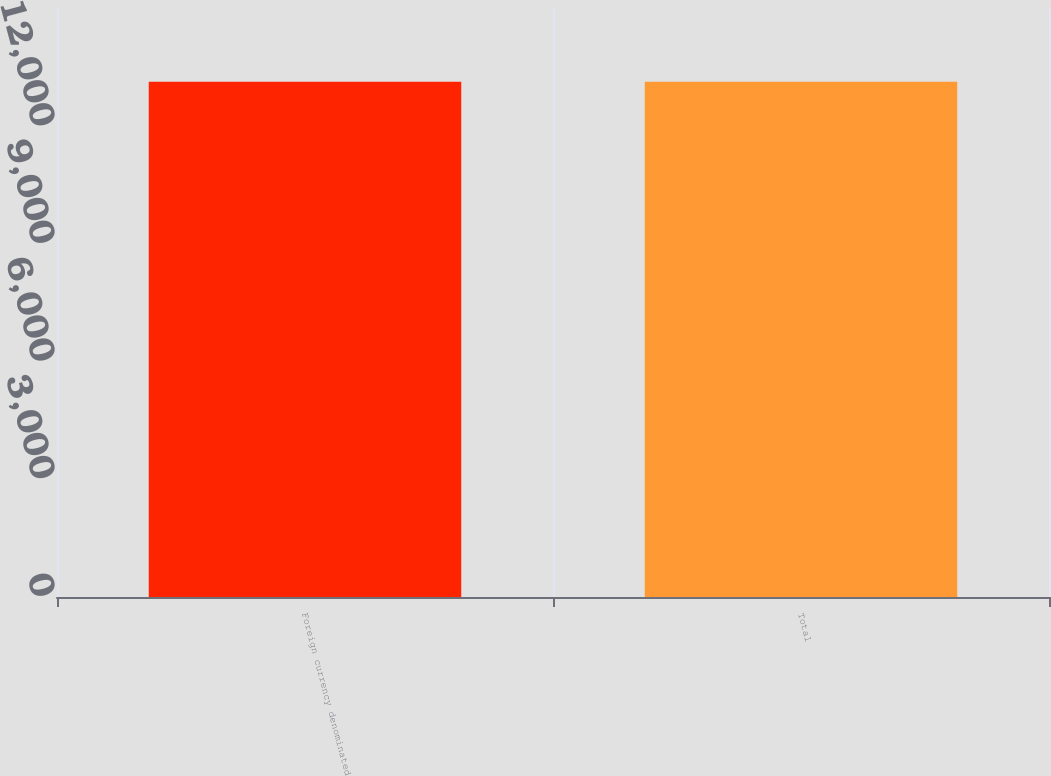Convert chart. <chart><loc_0><loc_0><loc_500><loc_500><bar_chart><fcel>Foreign currency denominated<fcel>Total<nl><fcel>13147<fcel>13147.1<nl></chart> 